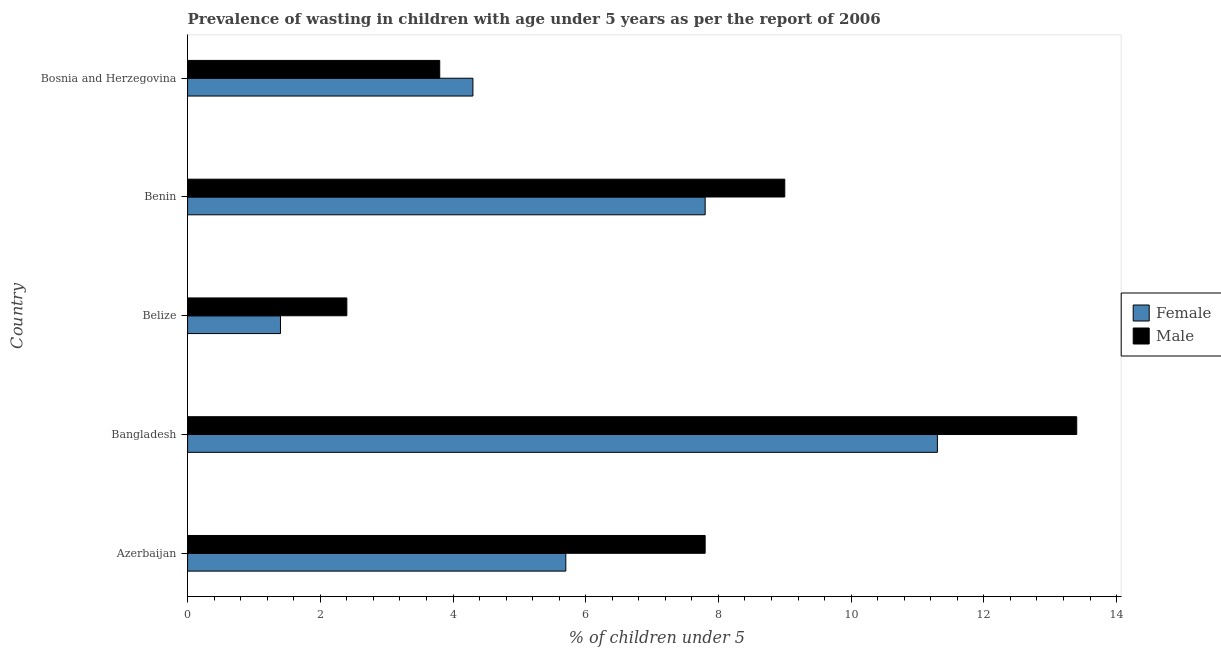How many groups of bars are there?
Your answer should be very brief. 5. Are the number of bars per tick equal to the number of legend labels?
Provide a short and direct response. Yes. Are the number of bars on each tick of the Y-axis equal?
Give a very brief answer. Yes. How many bars are there on the 3rd tick from the top?
Keep it short and to the point. 2. How many bars are there on the 3rd tick from the bottom?
Your answer should be compact. 2. What is the label of the 2nd group of bars from the top?
Your answer should be very brief. Benin. What is the percentage of undernourished female children in Azerbaijan?
Offer a very short reply. 5.7. Across all countries, what is the maximum percentage of undernourished female children?
Ensure brevity in your answer.  11.3. Across all countries, what is the minimum percentage of undernourished male children?
Make the answer very short. 2.4. In which country was the percentage of undernourished female children maximum?
Give a very brief answer. Bangladesh. In which country was the percentage of undernourished male children minimum?
Your answer should be compact. Belize. What is the total percentage of undernourished female children in the graph?
Your answer should be compact. 30.5. What is the difference between the percentage of undernourished male children in Azerbaijan and the percentage of undernourished female children in Belize?
Make the answer very short. 6.4. What is the average percentage of undernourished female children per country?
Offer a terse response. 6.1. What is the difference between the percentage of undernourished female children and percentage of undernourished male children in Bangladesh?
Provide a succinct answer. -2.1. What is the ratio of the percentage of undernourished male children in Bangladesh to that in Belize?
Provide a short and direct response. 5.58. Is the difference between the percentage of undernourished male children in Benin and Bosnia and Herzegovina greater than the difference between the percentage of undernourished female children in Benin and Bosnia and Herzegovina?
Your response must be concise. Yes. Is the sum of the percentage of undernourished male children in Azerbaijan and Benin greater than the maximum percentage of undernourished female children across all countries?
Provide a short and direct response. Yes. How many bars are there?
Your answer should be compact. 10. Are the values on the major ticks of X-axis written in scientific E-notation?
Provide a succinct answer. No. Does the graph contain grids?
Keep it short and to the point. No. Where does the legend appear in the graph?
Provide a short and direct response. Center right. How are the legend labels stacked?
Your answer should be very brief. Vertical. What is the title of the graph?
Make the answer very short. Prevalence of wasting in children with age under 5 years as per the report of 2006. What is the label or title of the X-axis?
Offer a terse response.  % of children under 5. What is the label or title of the Y-axis?
Ensure brevity in your answer.  Country. What is the  % of children under 5 in Female in Azerbaijan?
Your answer should be compact. 5.7. What is the  % of children under 5 in Male in Azerbaijan?
Your answer should be very brief. 7.8. What is the  % of children under 5 of Female in Bangladesh?
Your answer should be compact. 11.3. What is the  % of children under 5 of Male in Bangladesh?
Give a very brief answer. 13.4. What is the  % of children under 5 in Female in Belize?
Ensure brevity in your answer.  1.4. What is the  % of children under 5 in Male in Belize?
Ensure brevity in your answer.  2.4. What is the  % of children under 5 in Female in Benin?
Keep it short and to the point. 7.8. What is the  % of children under 5 in Male in Benin?
Provide a short and direct response. 9. What is the  % of children under 5 in Female in Bosnia and Herzegovina?
Your answer should be compact. 4.3. What is the  % of children under 5 in Male in Bosnia and Herzegovina?
Keep it short and to the point. 3.8. Across all countries, what is the maximum  % of children under 5 of Female?
Your response must be concise. 11.3. Across all countries, what is the maximum  % of children under 5 in Male?
Ensure brevity in your answer.  13.4. Across all countries, what is the minimum  % of children under 5 in Female?
Your answer should be very brief. 1.4. Across all countries, what is the minimum  % of children under 5 of Male?
Your answer should be very brief. 2.4. What is the total  % of children under 5 of Female in the graph?
Keep it short and to the point. 30.5. What is the total  % of children under 5 in Male in the graph?
Your answer should be very brief. 36.4. What is the difference between the  % of children under 5 of Female in Azerbaijan and that in Bangladesh?
Provide a short and direct response. -5.6. What is the difference between the  % of children under 5 of Female in Azerbaijan and that in Belize?
Provide a succinct answer. 4.3. What is the difference between the  % of children under 5 of Male in Azerbaijan and that in Belize?
Offer a terse response. 5.4. What is the difference between the  % of children under 5 of Female in Azerbaijan and that in Benin?
Offer a terse response. -2.1. What is the difference between the  % of children under 5 in Female in Azerbaijan and that in Bosnia and Herzegovina?
Provide a succinct answer. 1.4. What is the difference between the  % of children under 5 of Male in Azerbaijan and that in Bosnia and Herzegovina?
Your response must be concise. 4. What is the difference between the  % of children under 5 in Female in Bangladesh and that in Belize?
Your answer should be compact. 9.9. What is the difference between the  % of children under 5 in Female in Bangladesh and that in Bosnia and Herzegovina?
Ensure brevity in your answer.  7. What is the difference between the  % of children under 5 of Male in Bangladesh and that in Bosnia and Herzegovina?
Your answer should be very brief. 9.6. What is the difference between the  % of children under 5 of Female in Belize and that in Bosnia and Herzegovina?
Keep it short and to the point. -2.9. What is the difference between the  % of children under 5 of Male in Belize and that in Bosnia and Herzegovina?
Provide a succinct answer. -1.4. What is the difference between the  % of children under 5 in Female in Benin and that in Bosnia and Herzegovina?
Offer a terse response. 3.5. What is the difference between the  % of children under 5 of Female in Azerbaijan and the  % of children under 5 of Male in Belize?
Your answer should be very brief. 3.3. What is the difference between the  % of children under 5 in Female in Bangladesh and the  % of children under 5 in Male in Belize?
Your answer should be compact. 8.9. What is the difference between the  % of children under 5 of Female in Benin and the  % of children under 5 of Male in Bosnia and Herzegovina?
Your response must be concise. 4. What is the average  % of children under 5 in Male per country?
Offer a very short reply. 7.28. What is the difference between the  % of children under 5 in Female and  % of children under 5 in Male in Bangladesh?
Make the answer very short. -2.1. What is the difference between the  % of children under 5 of Female and  % of children under 5 of Male in Belize?
Offer a terse response. -1. What is the difference between the  % of children under 5 of Female and  % of children under 5 of Male in Bosnia and Herzegovina?
Keep it short and to the point. 0.5. What is the ratio of the  % of children under 5 in Female in Azerbaijan to that in Bangladesh?
Provide a succinct answer. 0.5. What is the ratio of the  % of children under 5 in Male in Azerbaijan to that in Bangladesh?
Make the answer very short. 0.58. What is the ratio of the  % of children under 5 in Female in Azerbaijan to that in Belize?
Your response must be concise. 4.07. What is the ratio of the  % of children under 5 of Female in Azerbaijan to that in Benin?
Your answer should be compact. 0.73. What is the ratio of the  % of children under 5 in Male in Azerbaijan to that in Benin?
Keep it short and to the point. 0.87. What is the ratio of the  % of children under 5 in Female in Azerbaijan to that in Bosnia and Herzegovina?
Provide a short and direct response. 1.33. What is the ratio of the  % of children under 5 in Male in Azerbaijan to that in Bosnia and Herzegovina?
Give a very brief answer. 2.05. What is the ratio of the  % of children under 5 of Female in Bangladesh to that in Belize?
Provide a short and direct response. 8.07. What is the ratio of the  % of children under 5 of Male in Bangladesh to that in Belize?
Your response must be concise. 5.58. What is the ratio of the  % of children under 5 in Female in Bangladesh to that in Benin?
Provide a succinct answer. 1.45. What is the ratio of the  % of children under 5 in Male in Bangladesh to that in Benin?
Your answer should be compact. 1.49. What is the ratio of the  % of children under 5 of Female in Bangladesh to that in Bosnia and Herzegovina?
Your answer should be compact. 2.63. What is the ratio of the  % of children under 5 in Male in Bangladesh to that in Bosnia and Herzegovina?
Offer a terse response. 3.53. What is the ratio of the  % of children under 5 in Female in Belize to that in Benin?
Keep it short and to the point. 0.18. What is the ratio of the  % of children under 5 of Male in Belize to that in Benin?
Offer a very short reply. 0.27. What is the ratio of the  % of children under 5 in Female in Belize to that in Bosnia and Herzegovina?
Make the answer very short. 0.33. What is the ratio of the  % of children under 5 of Male in Belize to that in Bosnia and Herzegovina?
Your answer should be very brief. 0.63. What is the ratio of the  % of children under 5 in Female in Benin to that in Bosnia and Herzegovina?
Offer a terse response. 1.81. What is the ratio of the  % of children under 5 in Male in Benin to that in Bosnia and Herzegovina?
Ensure brevity in your answer.  2.37. What is the difference between the highest and the second highest  % of children under 5 in Female?
Keep it short and to the point. 3.5. 